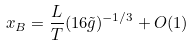Convert formula to latex. <formula><loc_0><loc_0><loc_500><loc_500>x _ { B } = \frac { L } { T } ( 1 6 \tilde { g } ) ^ { - 1 / 3 } + O ( 1 )</formula> 